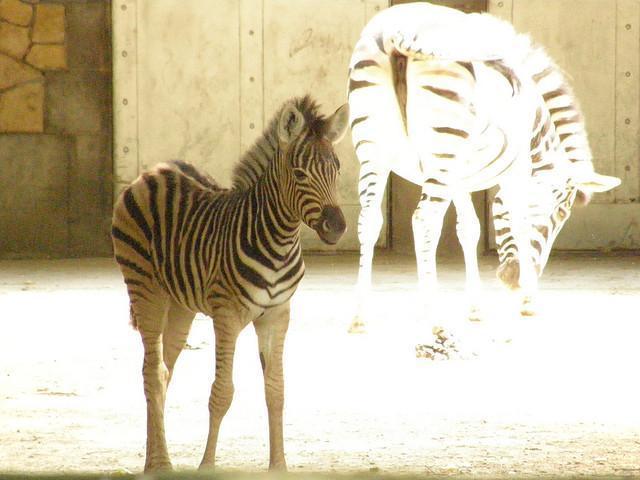How many zebras?
Give a very brief answer. 2. How many zebras are visible?
Give a very brief answer. 2. 